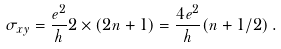<formula> <loc_0><loc_0><loc_500><loc_500>\sigma _ { x y } = \frac { e ^ { 2 } } { h } 2 \times ( 2 n + 1 ) = \frac { 4 e ^ { 2 } } { h } ( n + 1 / 2 ) \, .</formula> 